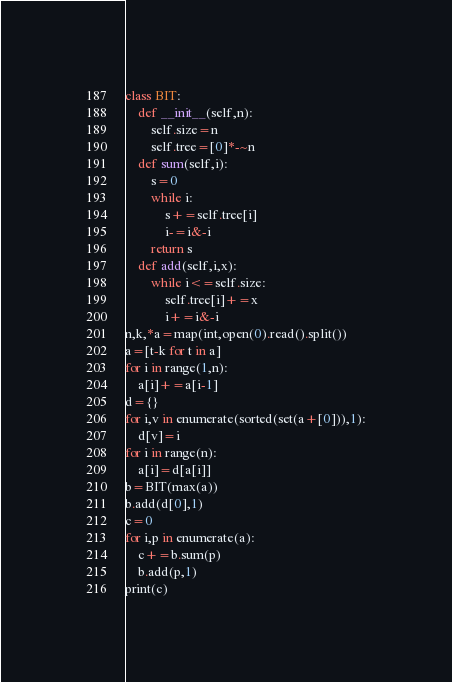<code> <loc_0><loc_0><loc_500><loc_500><_Python_>class BIT:
    def __init__(self,n):
        self.size=n
        self.tree=[0]*-~n
    def sum(self,i):
        s=0
        while i:
            s+=self.tree[i]
            i-=i&-i
        return s
    def add(self,i,x):
        while i<=self.size:
            self.tree[i]+=x
            i+=i&-i
n,k,*a=map(int,open(0).read().split())
a=[t-k for t in a]
for i in range(1,n):
    a[i]+=a[i-1]
d={}
for i,v in enumerate(sorted(set(a+[0])),1):
    d[v]=i
for i in range(n):
    a[i]=d[a[i]]
b=BIT(max(a))
b.add(d[0],1)
c=0
for i,p in enumerate(a):
    c+=b.sum(p)
    b.add(p,1)
print(c)</code> 